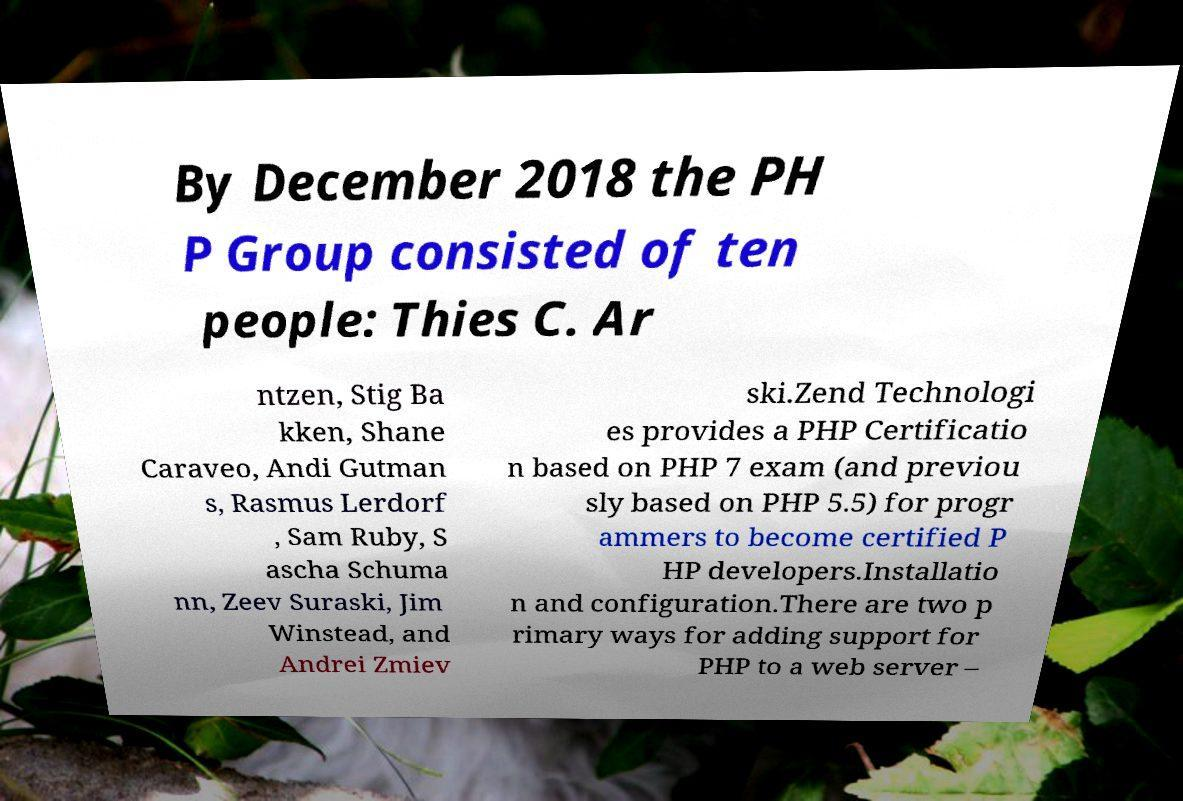Can you accurately transcribe the text from the provided image for me? By December 2018 the PH P Group consisted of ten people: Thies C. Ar ntzen, Stig Ba kken, Shane Caraveo, Andi Gutman s, Rasmus Lerdorf , Sam Ruby, S ascha Schuma nn, Zeev Suraski, Jim Winstead, and Andrei Zmiev ski.Zend Technologi es provides a PHP Certificatio n based on PHP 7 exam (and previou sly based on PHP 5.5) for progr ammers to become certified P HP developers.Installatio n and configuration.There are two p rimary ways for adding support for PHP to a web server – 